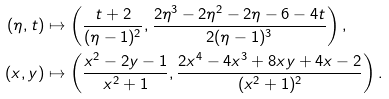<formula> <loc_0><loc_0><loc_500><loc_500>( \eta , t ) & \mapsto \left ( \frac { t + 2 } { ( \eta - 1 ) ^ { 2 } } , \frac { 2 \eta ^ { 3 } - 2 \eta ^ { 2 } - 2 \eta - 6 - 4 t } { 2 ( \eta - 1 ) ^ { 3 } } \right ) , \\ ( x , y ) & \mapsto \left ( \frac { x ^ { 2 } - 2 y - 1 } { x ^ { 2 } + 1 } , \frac { 2 x ^ { 4 } - 4 x ^ { 3 } + 8 x y + 4 x - 2 } { ( x ^ { 2 } + 1 ) ^ { 2 } } \right ) .</formula> 